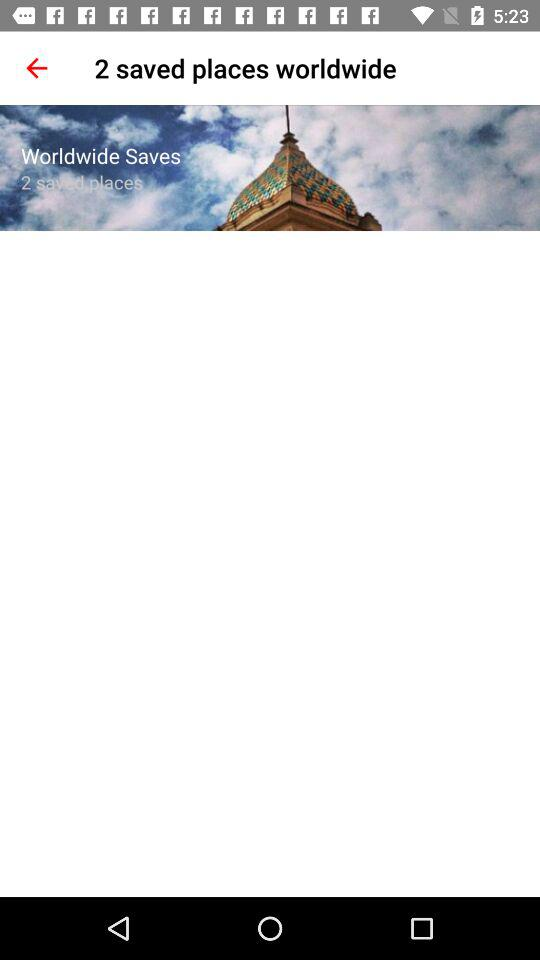How many saved places are there worldwide?
Answer the question using a single word or phrase. 2 